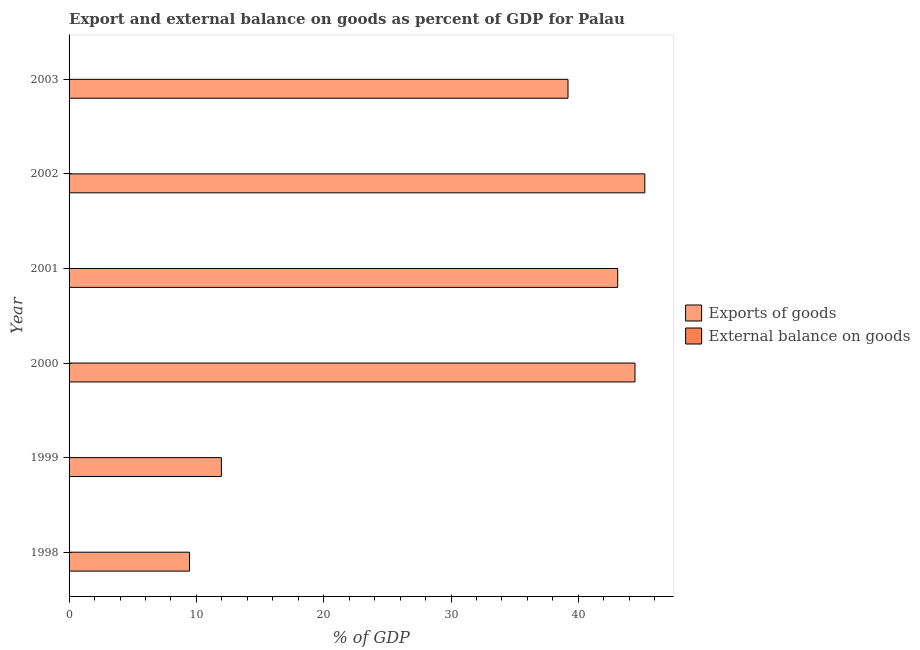How many bars are there on the 4th tick from the bottom?
Provide a short and direct response. 1. What is the label of the 6th group of bars from the top?
Your answer should be compact. 1998. What is the export of goods as percentage of gdp in 2001?
Provide a short and direct response. 43.09. Across all years, what is the maximum export of goods as percentage of gdp?
Your response must be concise. 45.22. Across all years, what is the minimum external balance on goods as percentage of gdp?
Ensure brevity in your answer.  0. In which year was the export of goods as percentage of gdp maximum?
Your answer should be very brief. 2002. What is the total export of goods as percentage of gdp in the graph?
Offer a very short reply. 193.35. What is the difference between the export of goods as percentage of gdp in 2000 and that in 2002?
Ensure brevity in your answer.  -0.77. What is the difference between the external balance on goods as percentage of gdp in 2000 and the export of goods as percentage of gdp in 2003?
Your answer should be very brief. -39.18. In how many years, is the external balance on goods as percentage of gdp greater than 4 %?
Make the answer very short. 0. What is the ratio of the export of goods as percentage of gdp in 1999 to that in 2000?
Provide a short and direct response. 0.27. Is the export of goods as percentage of gdp in 1999 less than that in 2002?
Make the answer very short. Yes. What is the difference between the highest and the second highest export of goods as percentage of gdp?
Make the answer very short. 0.77. What is the difference between the highest and the lowest export of goods as percentage of gdp?
Your answer should be very brief. 35.76. In how many years, is the external balance on goods as percentage of gdp greater than the average external balance on goods as percentage of gdp taken over all years?
Your answer should be very brief. 0. Are the values on the major ticks of X-axis written in scientific E-notation?
Keep it short and to the point. No. Does the graph contain any zero values?
Keep it short and to the point. Yes. How many legend labels are there?
Offer a very short reply. 2. How are the legend labels stacked?
Your response must be concise. Vertical. What is the title of the graph?
Offer a very short reply. Export and external balance on goods as percent of GDP for Palau. Does "State government" appear as one of the legend labels in the graph?
Offer a very short reply. No. What is the label or title of the X-axis?
Provide a short and direct response. % of GDP. What is the label or title of the Y-axis?
Ensure brevity in your answer.  Year. What is the % of GDP of Exports of goods in 1998?
Your response must be concise. 9.46. What is the % of GDP of Exports of goods in 1999?
Offer a very short reply. 11.96. What is the % of GDP in External balance on goods in 1999?
Give a very brief answer. 0. What is the % of GDP in Exports of goods in 2000?
Give a very brief answer. 44.45. What is the % of GDP in Exports of goods in 2001?
Provide a short and direct response. 43.09. What is the % of GDP in Exports of goods in 2002?
Make the answer very short. 45.22. What is the % of GDP in Exports of goods in 2003?
Ensure brevity in your answer.  39.18. What is the % of GDP in External balance on goods in 2003?
Provide a short and direct response. 0. Across all years, what is the maximum % of GDP of Exports of goods?
Ensure brevity in your answer.  45.22. Across all years, what is the minimum % of GDP of Exports of goods?
Keep it short and to the point. 9.46. What is the total % of GDP in Exports of goods in the graph?
Give a very brief answer. 193.35. What is the difference between the % of GDP of Exports of goods in 1998 and that in 1999?
Provide a succinct answer. -2.5. What is the difference between the % of GDP in Exports of goods in 1998 and that in 2000?
Your answer should be very brief. -34.99. What is the difference between the % of GDP in Exports of goods in 1998 and that in 2001?
Your answer should be compact. -33.63. What is the difference between the % of GDP in Exports of goods in 1998 and that in 2002?
Your answer should be compact. -35.76. What is the difference between the % of GDP of Exports of goods in 1998 and that in 2003?
Your answer should be compact. -29.73. What is the difference between the % of GDP in Exports of goods in 1999 and that in 2000?
Make the answer very short. -32.48. What is the difference between the % of GDP of Exports of goods in 1999 and that in 2001?
Make the answer very short. -31.13. What is the difference between the % of GDP in Exports of goods in 1999 and that in 2002?
Offer a very short reply. -33.26. What is the difference between the % of GDP in Exports of goods in 1999 and that in 2003?
Make the answer very short. -27.22. What is the difference between the % of GDP in Exports of goods in 2000 and that in 2001?
Provide a succinct answer. 1.36. What is the difference between the % of GDP in Exports of goods in 2000 and that in 2002?
Provide a succinct answer. -0.77. What is the difference between the % of GDP in Exports of goods in 2000 and that in 2003?
Provide a short and direct response. 5.26. What is the difference between the % of GDP of Exports of goods in 2001 and that in 2002?
Provide a succinct answer. -2.13. What is the difference between the % of GDP in Exports of goods in 2001 and that in 2003?
Offer a terse response. 3.9. What is the difference between the % of GDP in Exports of goods in 2002 and that in 2003?
Provide a short and direct response. 6.03. What is the average % of GDP of Exports of goods per year?
Give a very brief answer. 32.23. What is the average % of GDP of External balance on goods per year?
Ensure brevity in your answer.  0. What is the ratio of the % of GDP of Exports of goods in 1998 to that in 1999?
Your answer should be very brief. 0.79. What is the ratio of the % of GDP of Exports of goods in 1998 to that in 2000?
Offer a very short reply. 0.21. What is the ratio of the % of GDP in Exports of goods in 1998 to that in 2001?
Your response must be concise. 0.22. What is the ratio of the % of GDP in Exports of goods in 1998 to that in 2002?
Give a very brief answer. 0.21. What is the ratio of the % of GDP of Exports of goods in 1998 to that in 2003?
Your answer should be very brief. 0.24. What is the ratio of the % of GDP in Exports of goods in 1999 to that in 2000?
Offer a very short reply. 0.27. What is the ratio of the % of GDP of Exports of goods in 1999 to that in 2001?
Offer a terse response. 0.28. What is the ratio of the % of GDP of Exports of goods in 1999 to that in 2002?
Offer a terse response. 0.26. What is the ratio of the % of GDP of Exports of goods in 1999 to that in 2003?
Your answer should be compact. 0.31. What is the ratio of the % of GDP in Exports of goods in 2000 to that in 2001?
Keep it short and to the point. 1.03. What is the ratio of the % of GDP in Exports of goods in 2000 to that in 2002?
Your response must be concise. 0.98. What is the ratio of the % of GDP in Exports of goods in 2000 to that in 2003?
Give a very brief answer. 1.13. What is the ratio of the % of GDP in Exports of goods in 2001 to that in 2002?
Ensure brevity in your answer.  0.95. What is the ratio of the % of GDP of Exports of goods in 2001 to that in 2003?
Offer a very short reply. 1.1. What is the ratio of the % of GDP in Exports of goods in 2002 to that in 2003?
Keep it short and to the point. 1.15. What is the difference between the highest and the second highest % of GDP in Exports of goods?
Your answer should be compact. 0.77. What is the difference between the highest and the lowest % of GDP of Exports of goods?
Your response must be concise. 35.76. 